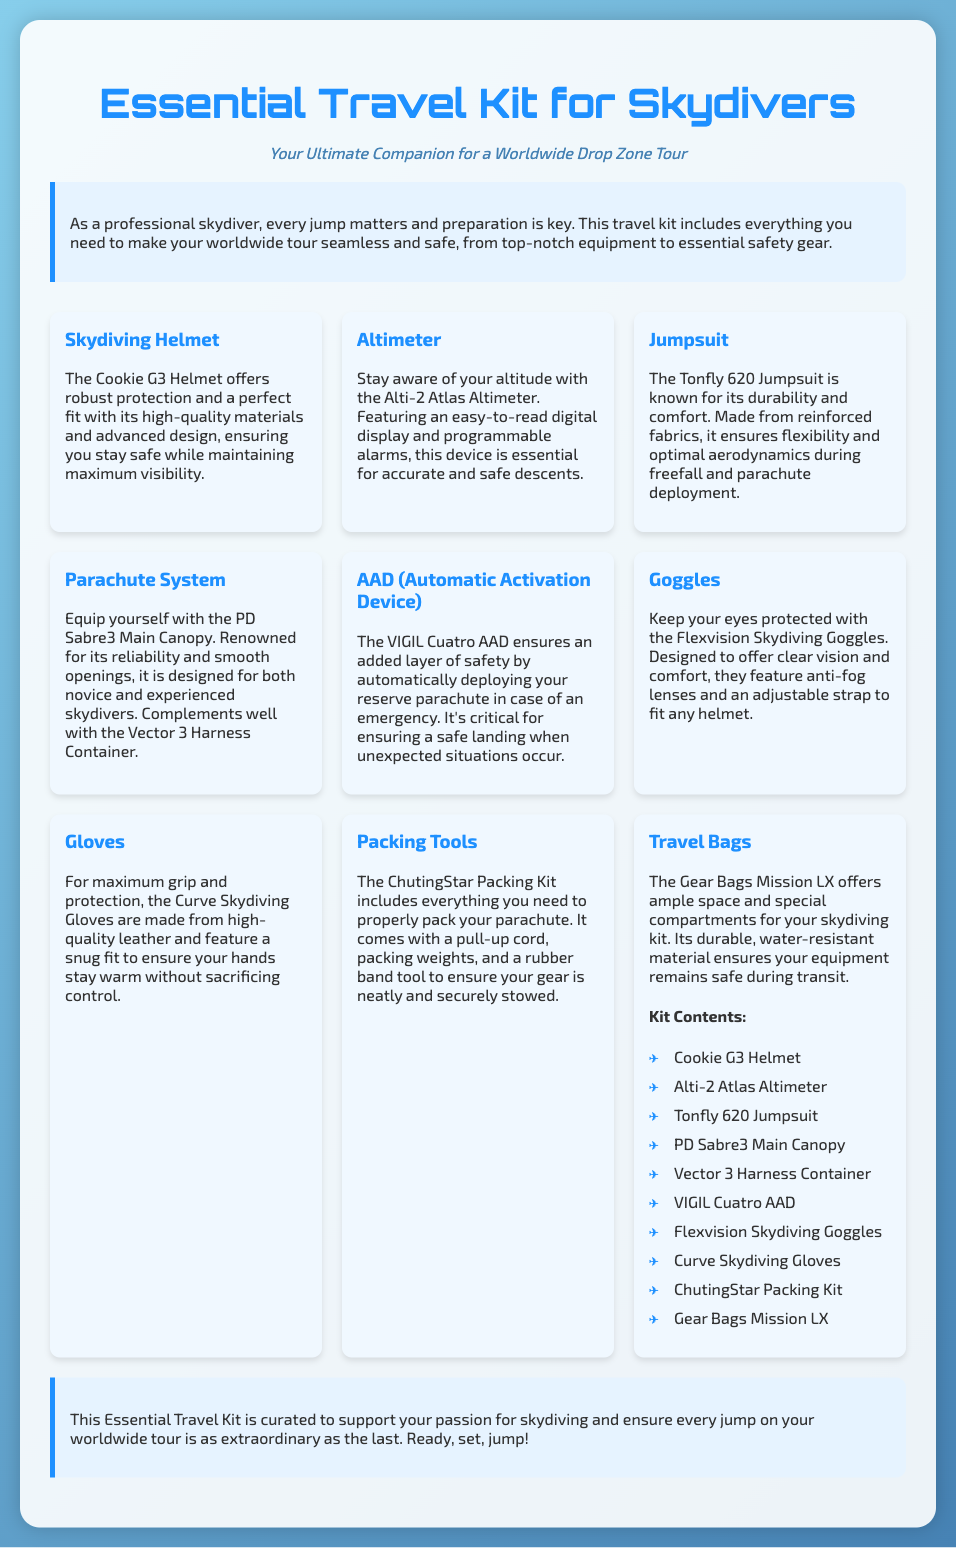What is the name of the helmet in the kit? The document mentions “The Cookie G3 Helmet” as the helmet included in the kit.
Answer: Cookie G3 Helmet What is the function of the Alti-2 Atlas Altimeter? The document specifies that it helps maintain altitude awareness.
Answer: Maintain altitude awareness What is the recommended use of the PD Sabre3 Main Canopy? The document states that it is designed for both novice and experienced skydivers.
Answer: Both novice and experienced skydivers What safety device is included in the kit for emergency situations? The document indicates that the VIGIL Cuatro AAD is included for safety.
Answer: VIGIL Cuatro AAD Which item helps protect the eyes during a jump? According to the document, the Flexvision Skydiving Goggles help protect the eyes.
Answer: Flexvision Skydiving Goggles How many items are listed in the kit contents? The document lists a total of ten items in the kit contents section.
Answer: Ten items What material are the Curve Skydiving Gloves made from? The document states that the gloves are made from high-quality leather.
Answer: High-quality leather What is the purpose of the ChutingStar Packing Kit? The document describes the packing kit is used for packing the parachute properly.
Answer: Packing the parachute properly What feature does the Gear Bags Mission LX offer? The document mentions that it provides ample space and special compartments for gear.
Answer: Ample space and special compartments 